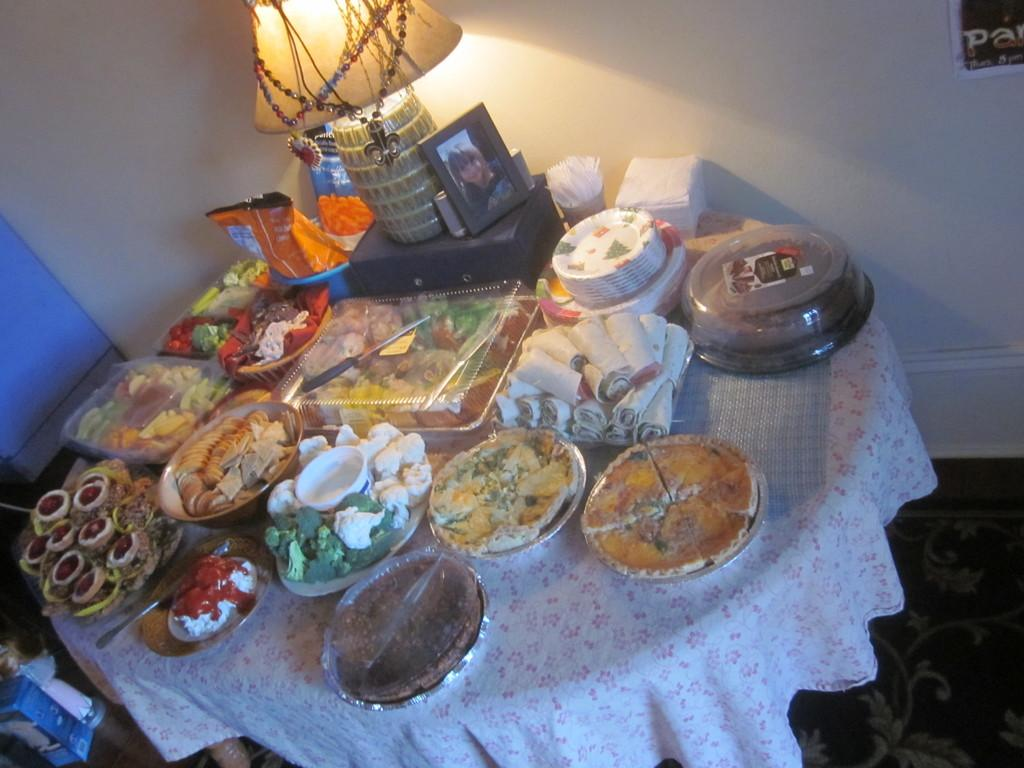What type of furniture is present in the image? There is a table in the image. What is placed on the table? There are food items displayed on the table. What is located beside the table? There is a lamp and a photo frame beside the table. Can you see a kite being flown in the image? No, there is no kite present in the image. What type of gardening tool is visible in the image? There is no gardening tool, such as a spade, present in the image. 